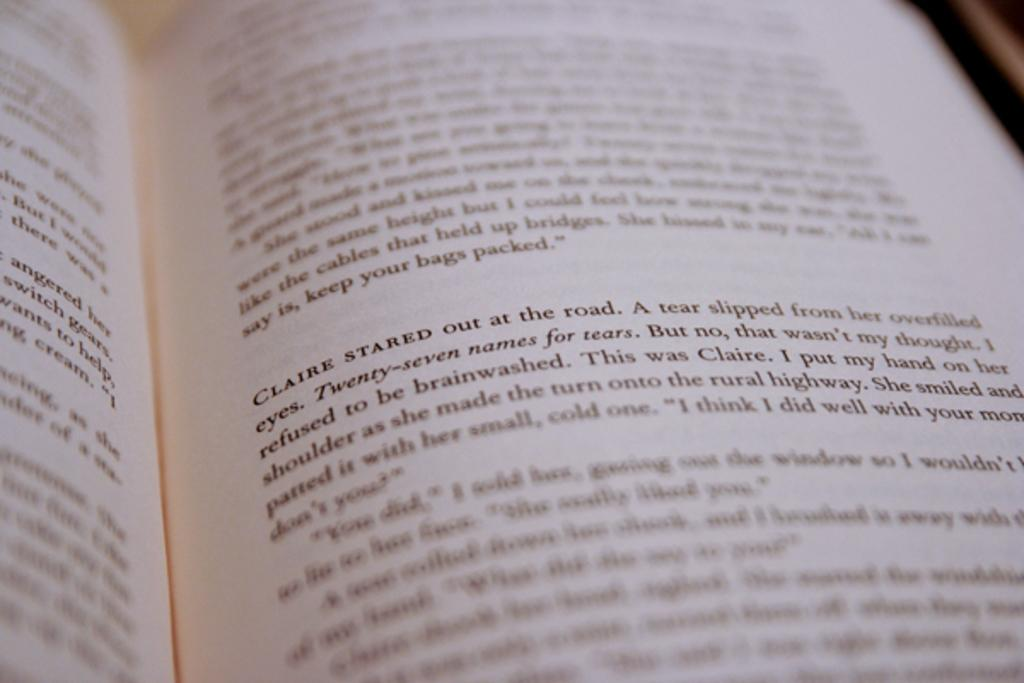<image>
Give a short and clear explanation of the subsequent image. A page of a book that includes a character named Claire. 